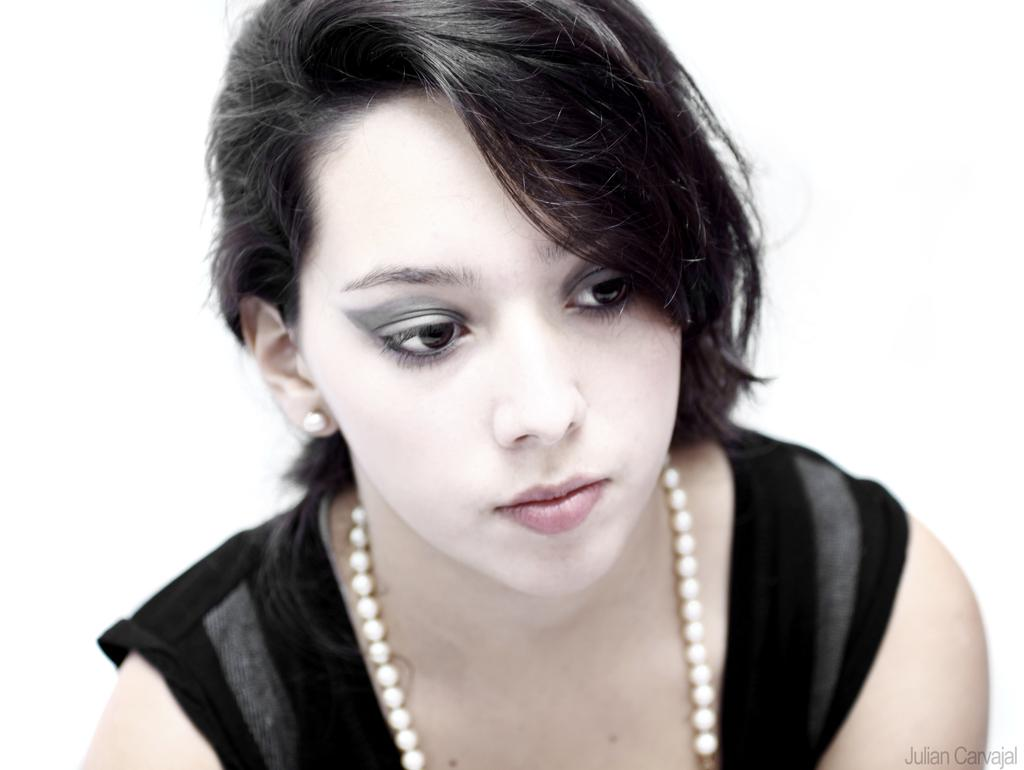Who is the main subject in the image? There is a woman in the image. What is the woman wearing? The woman is wearing a black dress. What level of experience does the woman have in the office setting in the image? The image does not provide any information about the woman's experience level or the setting being an office. 